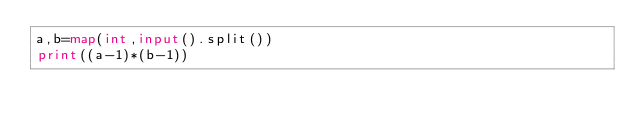<code> <loc_0><loc_0><loc_500><loc_500><_Python_>a,b=map(int,input().split())
print((a-1)*(b-1))</code> 